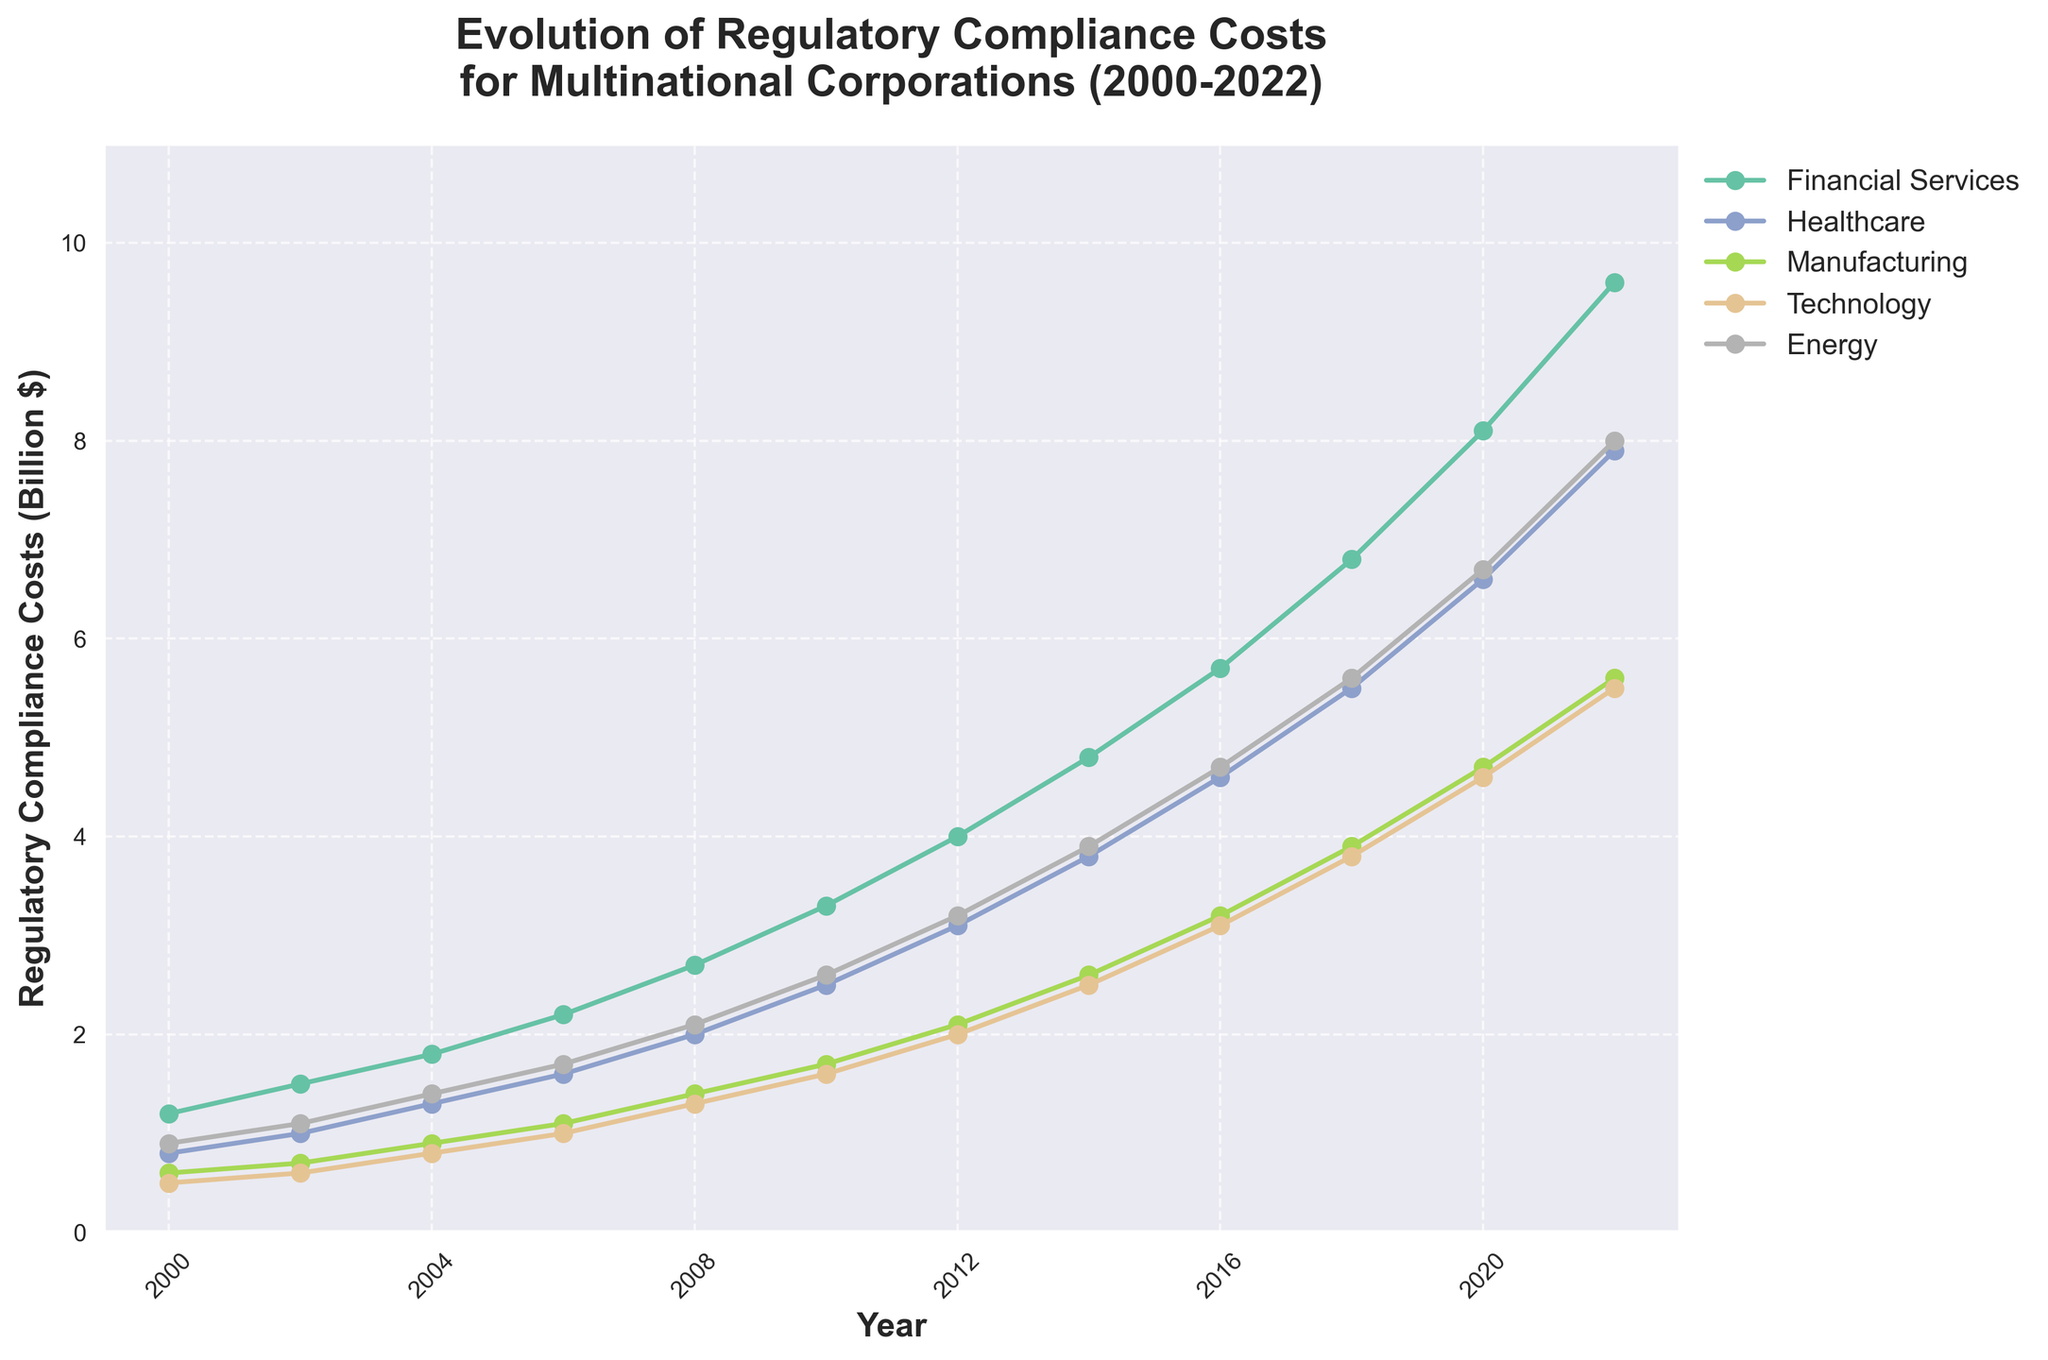What's the trend observed in regulatory compliance costs for the Financial Services industry from 2000 to 2022? The plot shows a line steadily increasing from 1.2 billion dollars in 2000 to 9.6 billion dollars in 2022 for the Financial Services industry, indicating a continuous rise over time.
Answer: Continuous increase Which industry had the lowest regulatory compliance costs in 2022? By looking at the endpoints of the lines on the right side of the plot, Technology had the lowest cost at 5.5 billion dollars in 2022.
Answer: Technology How much did the regulatory compliance costs for the Energy industry increase between 2010 and 2016? From the chart, the cost for the Energy industry in 2010 was 2.6 billion dollars and in 2016 was 4.7 billion dollars. The increase is 4.7 - 2.6 = 2.1 billion dollars.
Answer: 2.1 billion dollars Which industry experienced the highest growth rate in regulatory compliance costs between 2000 and 2022? By comparing the start and end values and their differences for all industries: Financial Services increased from 1.2 to 9.6 (8.4 increase), Healthcare from 0.8 to 7.9 (7.1 increase), Manufacturing from 0.6 to 5.6 (5.0 increase), Technology from 0.5 to 5.5 (5.0 increase), and Energy from 0.9 to 8.0 (7.1 increase); Financial Services had the highest absolute growth.
Answer: Financial Services In what year did the regulatory compliance costs for the Healthcare industry surpass those for the Manufacturing and Technology industries? From 2004, the Healthcare costs line, starting at 1.3 billion dollars, surpasses both Manufacturing at 0.9 billion dollars and Technology at 0.8 billion dollars.
Answer: 2004 What's the average regulatory compliance cost of the Manufacturing industry from 2000 to 2022? Sum the values from the Manufacturing industry line: (0.6 + 0.7 + 0.9 + 1.1 + 1.4 + 1.7 + 2.1 + 2.6 + 3.2 + 3.9 + 4.7 + 5.6) = 28.5. There are 12 data points, so the average is 28.5 / 12 = 2.375.
Answer: 2.375 billion dollars How do the costs for the Technology industry in 2020 compare to those in 2008? In 2008, the cost is 1.3 billion dollars, and in 2020, it is 4.6 billion dollars. Thus, the cost in 2020 is higher by 4.6 - 1.3 = 3.3 billion dollars.
Answer: 3.3 billion dollars higher Which two industries had the closest regulatory compliance costs in 2018? By looking for lines with close vertical values in 2018, Manufacturing at 3.9 billion dollars and Technology at 3.8 billion dollars are the closest.
Answer: Manufacturing and Technology What is the total regulatory compliance cost for all industries combined in 2022? Sum the values for all industries in 2022: (9.6 + 7.9 + 5.6 + 5.5 + 8.0) = 36.6 billion dollars.
Answer: 36.6 billion dollars 